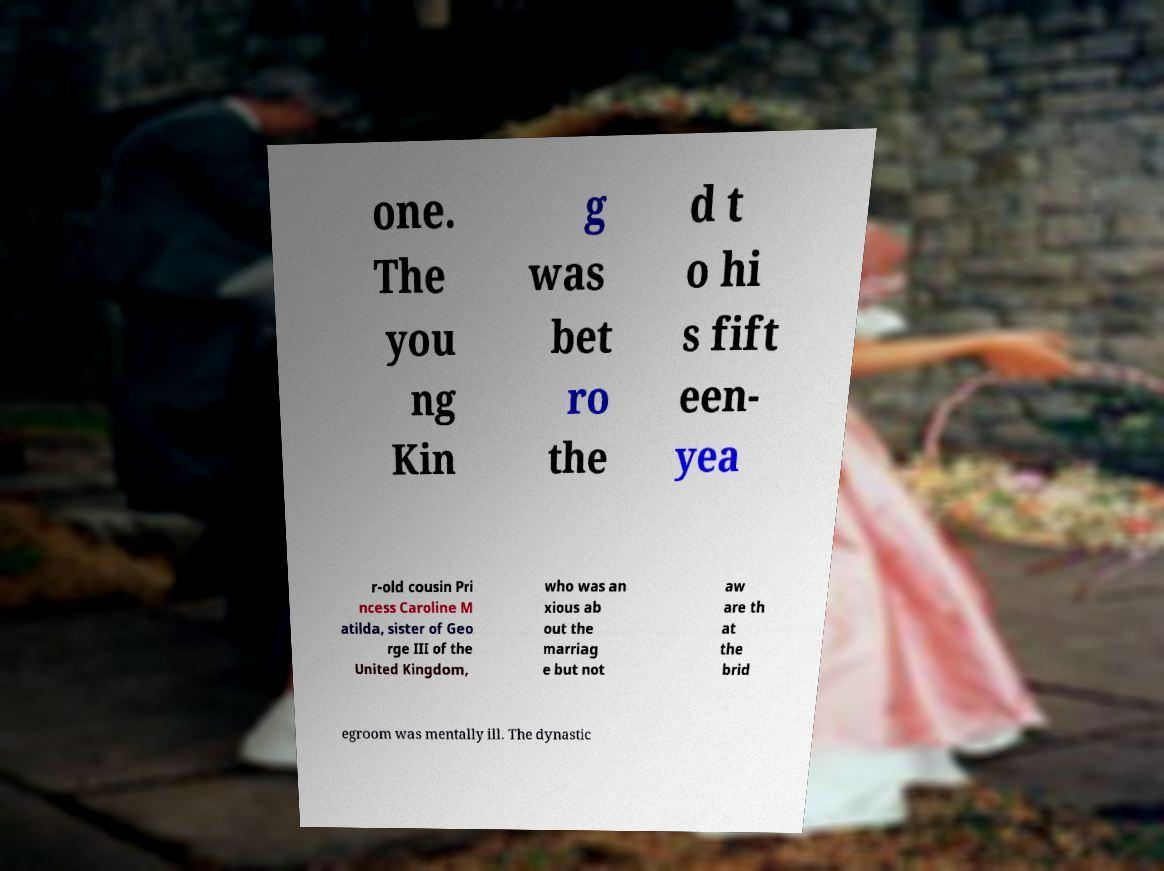Could you assist in decoding the text presented in this image and type it out clearly? one. The you ng Kin g was bet ro the d t o hi s fift een- yea r-old cousin Pri ncess Caroline M atilda, sister of Geo rge III of the United Kingdom, who was an xious ab out the marriag e but not aw are th at the brid egroom was mentally ill. The dynastic 